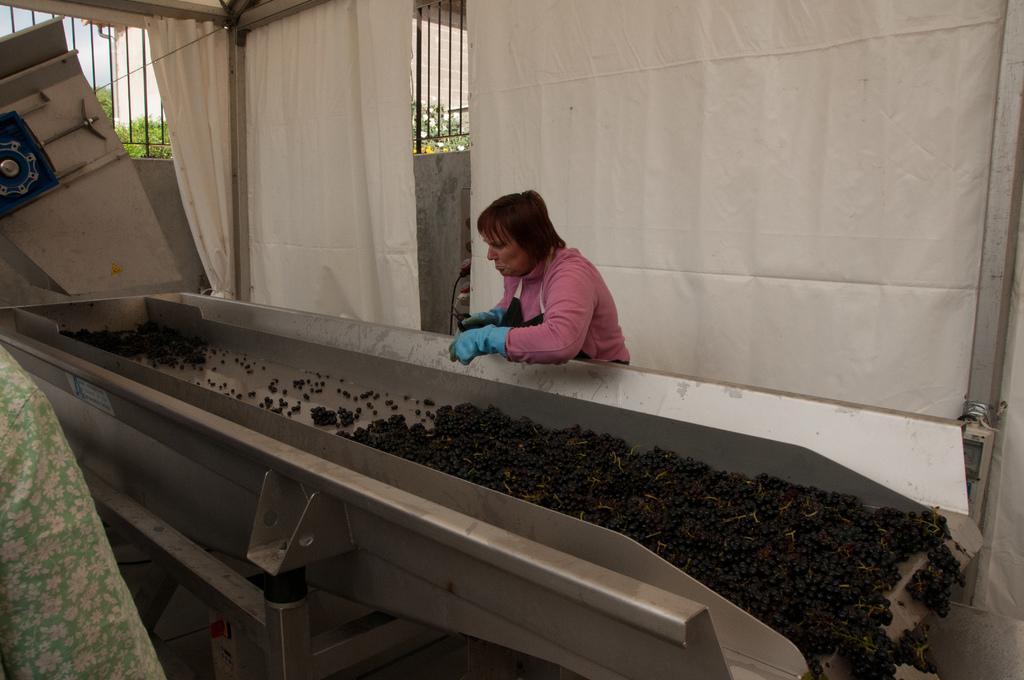How would you summarize this image in a sentence or two? In this image in the center there is one woman who is standing, and in front of her there is one machine. And in that machine there are some berries, in the background there are some windows and curtains. 